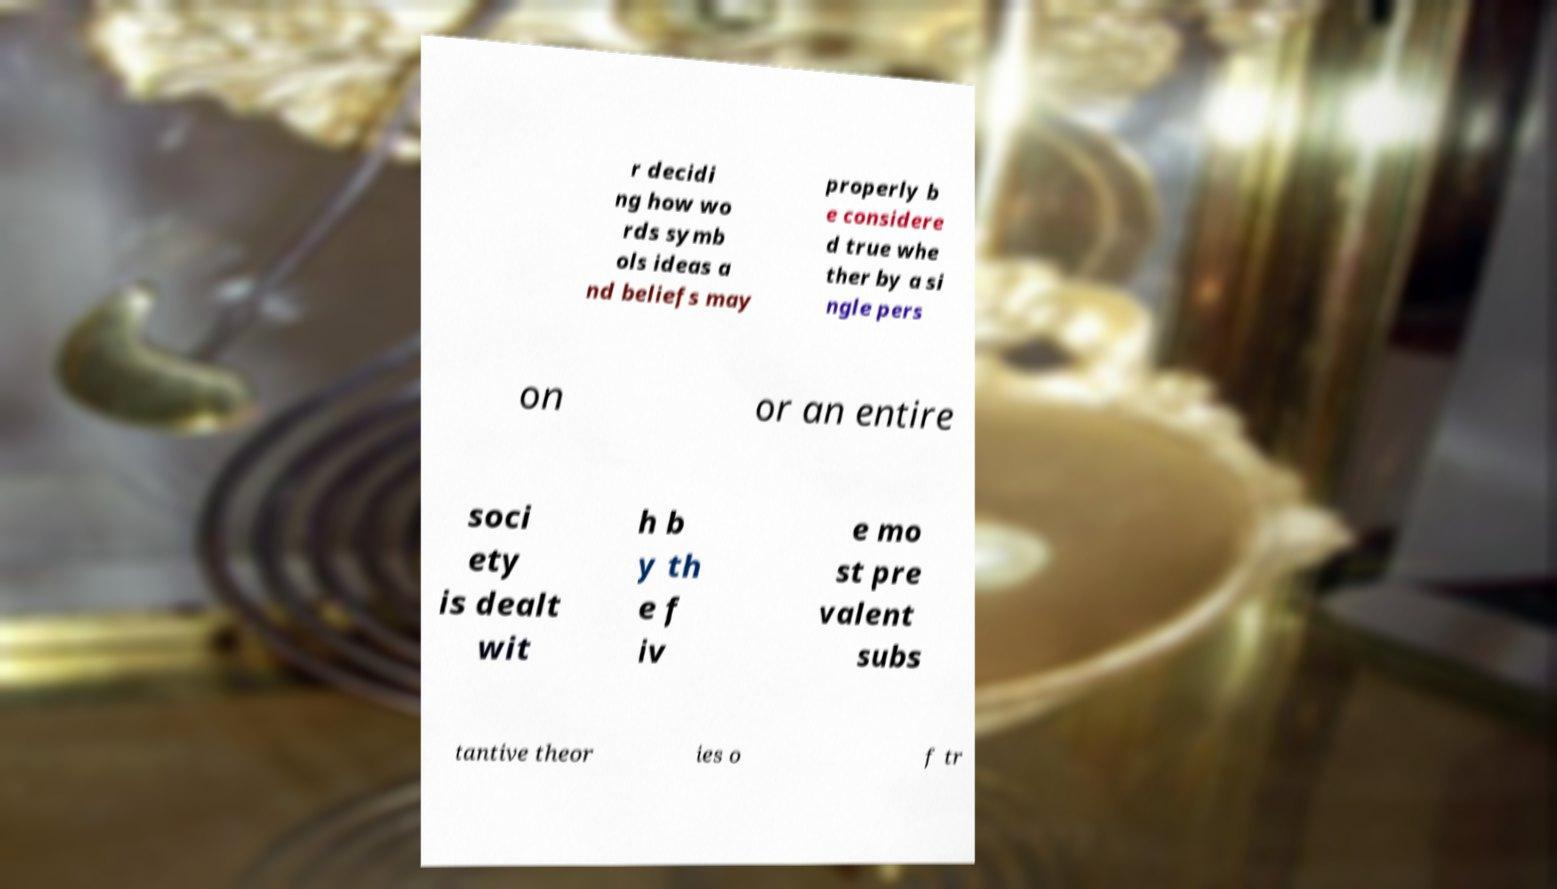Could you extract and type out the text from this image? r decidi ng how wo rds symb ols ideas a nd beliefs may properly b e considere d true whe ther by a si ngle pers on or an entire soci ety is dealt wit h b y th e f iv e mo st pre valent subs tantive theor ies o f tr 